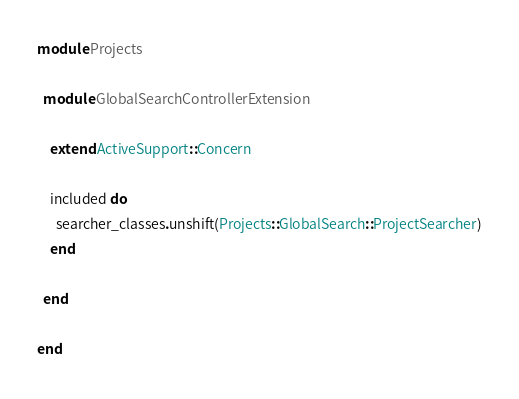<code> <loc_0><loc_0><loc_500><loc_500><_Ruby_>module Projects

  module GlobalSearchControllerExtension

    extend ActiveSupport::Concern

    included do
      searcher_classes.unshift(Projects::GlobalSearch::ProjectSearcher)
    end

  end

end
</code> 